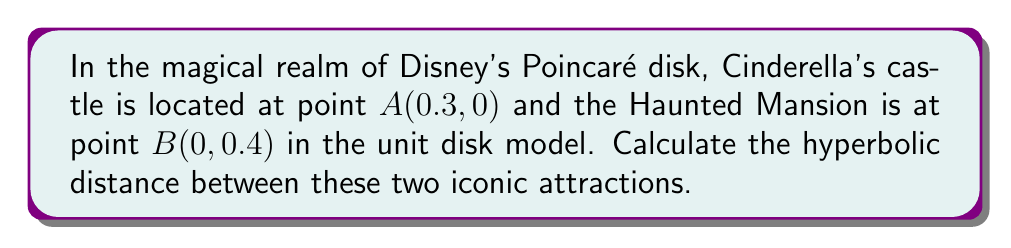Give your solution to this math problem. To solve this problem, we'll use the formula for the hyperbolic distance between two points in the Poincaré disk model. Let's approach this step-by-step:

1) The formula for the hyperbolic distance $d$ between two points $z_1$ and $z_2$ in the Poincaré disk model is:

   $$d = 2\tanh^{-1}\left(\frac{|z_1-z_2|}{\sqrt{(1-|z_1|^2)(1-|z_2|^2)}}\right)$$

2) In our case, $z_1 = 0.3 + 0i$ and $z_2 = 0 + 0.4i$

3) Let's calculate $|z_1-z_2|$:
   $$|z_1-z_2| = \sqrt{(0.3-0)^2 + (0-0.4)^2} = \sqrt{0.09 + 0.16} = \sqrt{0.25} = 0.5$$

4) Now, let's calculate $|z_1|^2$ and $|z_2|^2$:
   $$|z_1|^2 = 0.3^2 = 0.09$$
   $$|z_2|^2 = 0.4^2 = 0.16$$

5) We can now calculate $(1-|z_1|^2)(1-|z_2|^2)$:
   $$(1-0.09)(1-0.16) = 0.91 \times 0.84 = 0.7644$$

6) Substituting these values into our formula:

   $$d = 2\tanh^{-1}\left(\frac{0.5}{\sqrt{0.7644}}\right) = 2\tanh^{-1}\left(\frac{0.5}{0.8743}\right)$$

7) Simplifying:
   $$d = 2\tanh^{-1}(0.5719) \approx 1.2984$$

Therefore, the hyperbolic distance between Cinderella's castle and the Haunted Mansion in this magical Disney Poincaré disk is approximately 1.2984 units.

[asy]
unitsize(100);
draw(circle((0,0),1));
dot((0.3,0),red);
dot((0,0.4),blue);
label("A (Castle)", (0.3,0), E, red);
label("B (Haunted Mansion)", (0,0.4), N, blue);
[/asy]
Answer: $1.2984$ units 